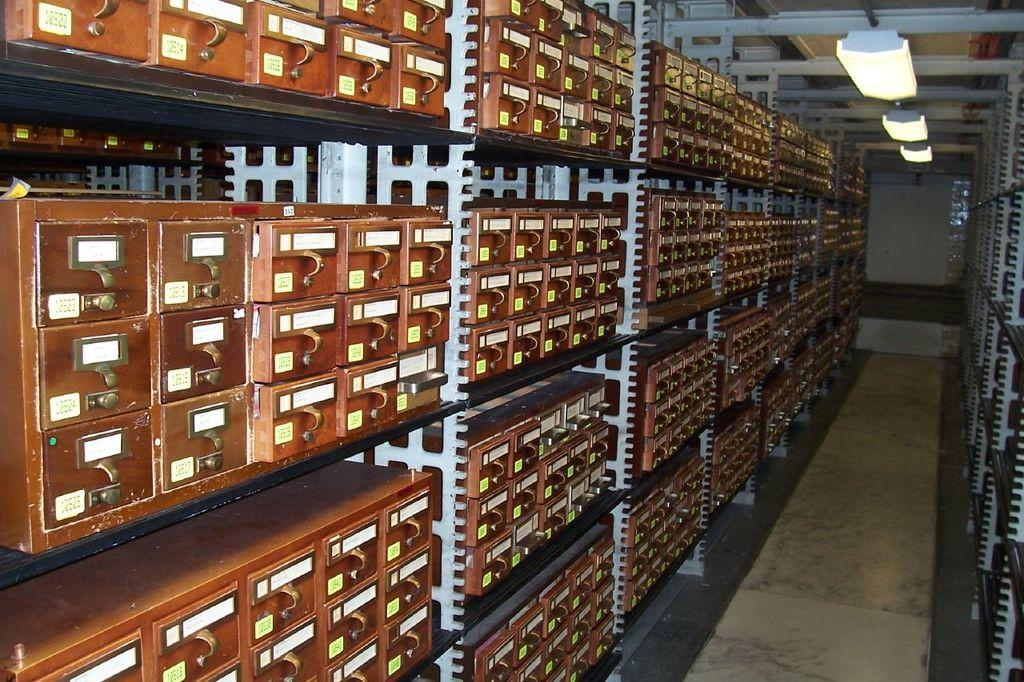What type of objects are in the image? There are wooden boxes in the image. How are the wooden boxes arranged? The wooden boxes are in racks. What can be seen in the background of the image? There are lights visible in the background of the image. What type of fruit is being sorted by the grandfather in the image? There is no grandfather or fruit sorting present in the image; it features wooden boxes in racks and lights in the background. 